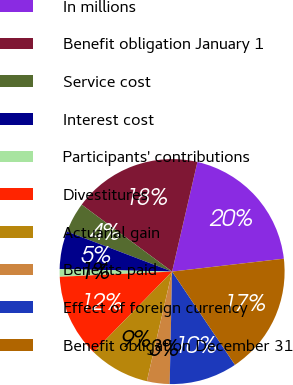Convert chart to OTSL. <chart><loc_0><loc_0><loc_500><loc_500><pie_chart><fcel>In millions<fcel>Benefit obligation January 1<fcel>Service cost<fcel>Interest cost<fcel>Participants' contributions<fcel>Divestitures<fcel>Actuarial gain<fcel>Benefits paid<fcel>Effect of foreign currency<fcel>Benefit obligation December 31<nl><fcel>19.56%<fcel>18.47%<fcel>4.35%<fcel>5.44%<fcel>1.09%<fcel>11.96%<fcel>8.7%<fcel>3.26%<fcel>9.78%<fcel>17.39%<nl></chart> 